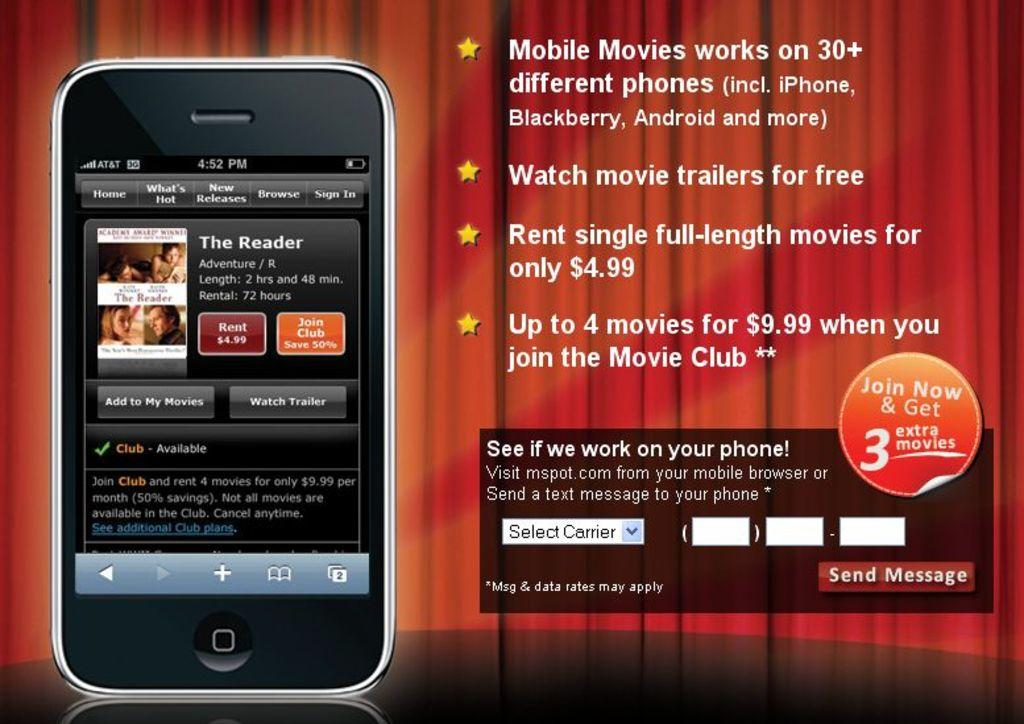Provide a one-sentence caption for the provided image. An advertisement for a movie streaming service that lets people watch movie trailers for free. 